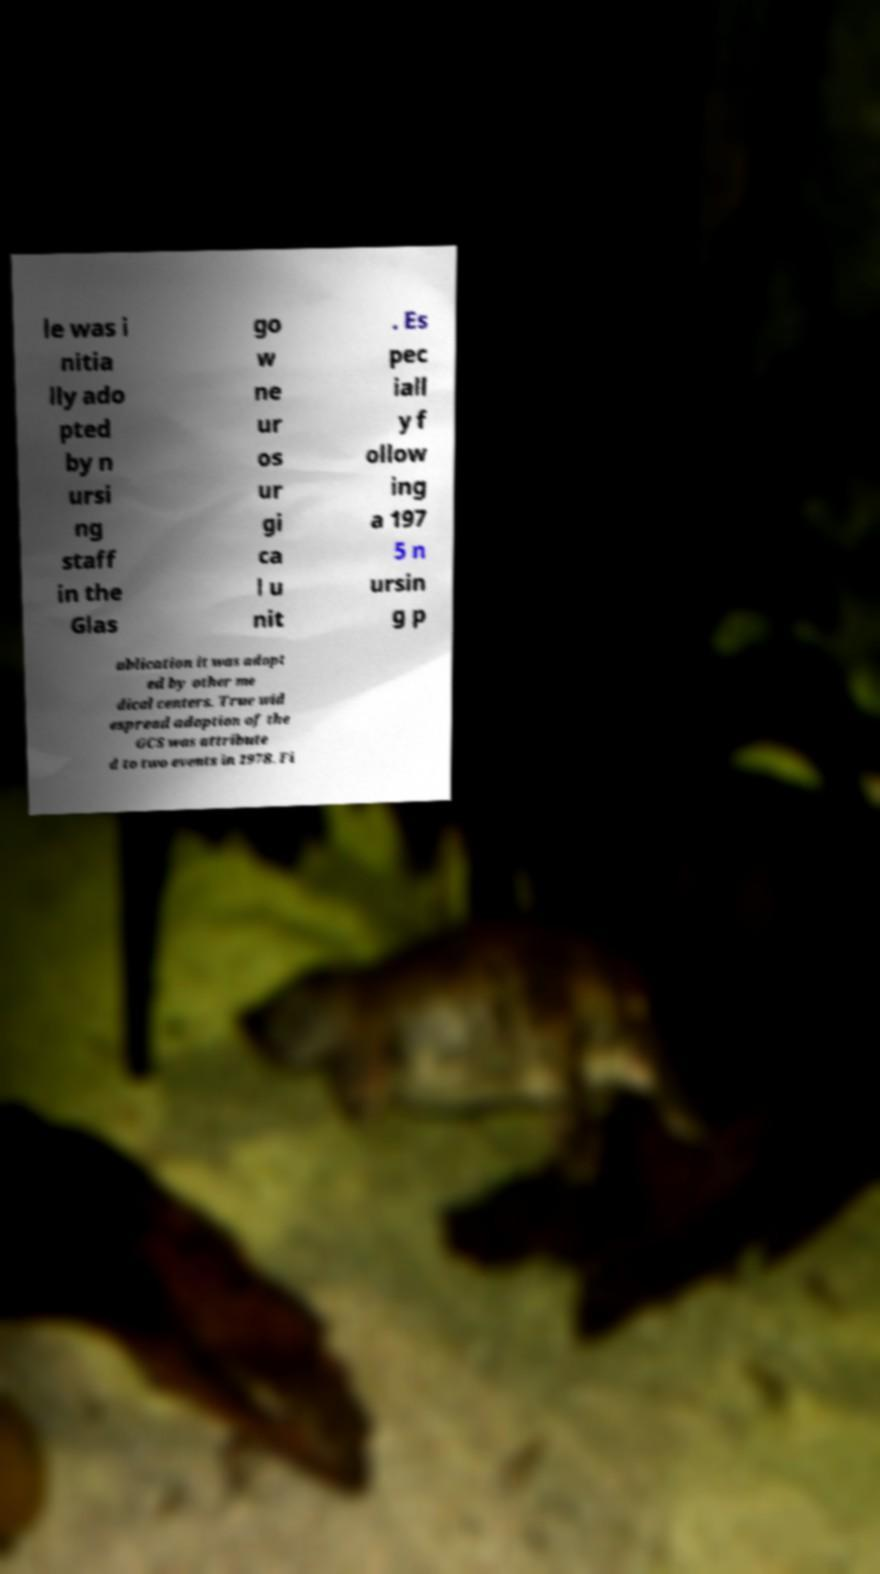There's text embedded in this image that I need extracted. Can you transcribe it verbatim? le was i nitia lly ado pted by n ursi ng staff in the Glas go w ne ur os ur gi ca l u nit . Es pec iall y f ollow ing a 197 5 n ursin g p ublication it was adopt ed by other me dical centers. True wid espread adoption of the GCS was attribute d to two events in 1978. Fi 